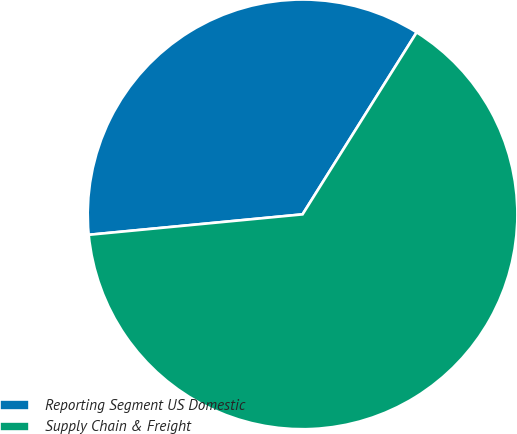Convert chart. <chart><loc_0><loc_0><loc_500><loc_500><pie_chart><fcel>Reporting Segment US Domestic<fcel>Supply Chain & Freight<nl><fcel>35.43%<fcel>64.57%<nl></chart> 